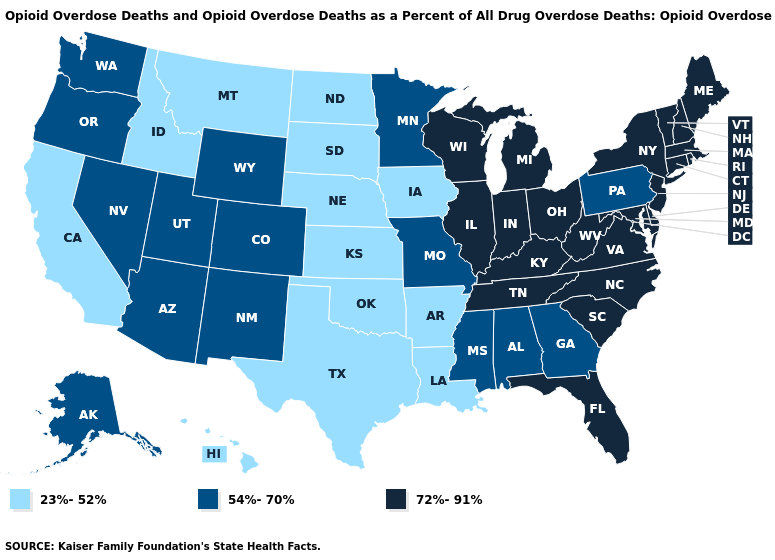What is the value of New Jersey?
Be succinct. 72%-91%. Which states have the lowest value in the MidWest?
Write a very short answer. Iowa, Kansas, Nebraska, North Dakota, South Dakota. Does the map have missing data?
Short answer required. No. Does South Carolina have the same value as Indiana?
Write a very short answer. Yes. What is the value of West Virginia?
Answer briefly. 72%-91%. Does the map have missing data?
Quick response, please. No. Which states hav the highest value in the South?
Quick response, please. Delaware, Florida, Kentucky, Maryland, North Carolina, South Carolina, Tennessee, Virginia, West Virginia. Among the states that border Delaware , does Pennsylvania have the highest value?
Concise answer only. No. Among the states that border Oregon , which have the lowest value?
Be succinct. California, Idaho. What is the value of North Carolina?
Answer briefly. 72%-91%. Does Ohio have the highest value in the MidWest?
Quick response, please. Yes. What is the lowest value in the USA?
Concise answer only. 23%-52%. Does the map have missing data?
Concise answer only. No. Does the first symbol in the legend represent the smallest category?
Answer briefly. Yes. Does California have the highest value in the USA?
Be succinct. No. 